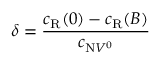<formula> <loc_0><loc_0><loc_500><loc_500>\delta = \frac { c _ { R } ( 0 ) - c _ { R } ( B ) } { c _ { N V ^ { 0 } } }</formula> 